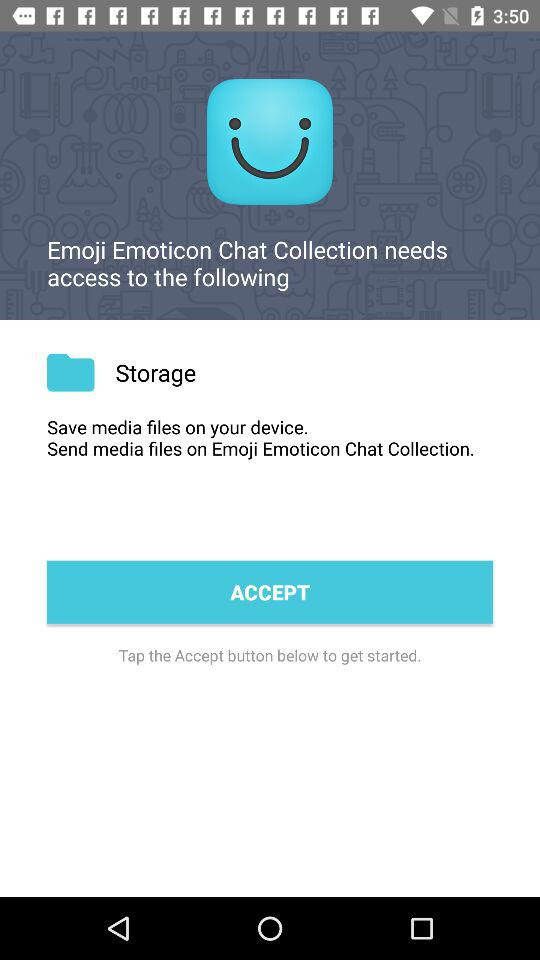Where can we save media files? You can save media files on your device. 